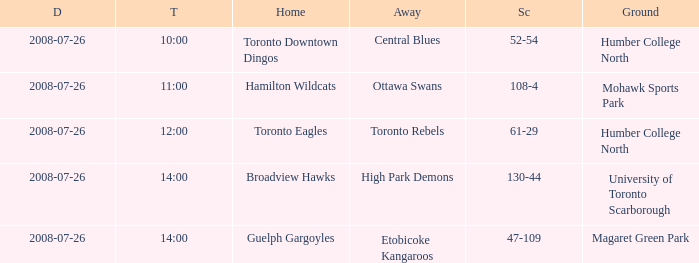Who has the Home Score of 52-54? Toronto Downtown Dingos. 